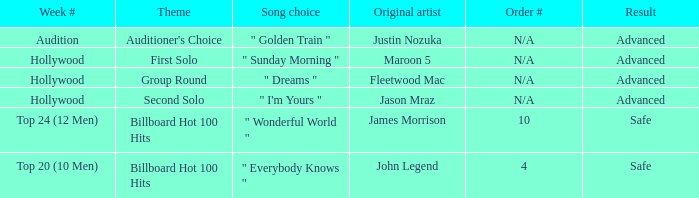What are all the week # where subject matter is auditioner's choice Audition. 